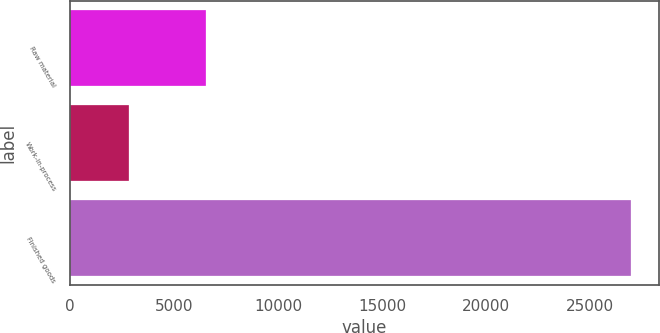<chart> <loc_0><loc_0><loc_500><loc_500><bar_chart><fcel>Raw material<fcel>Work-in-process<fcel>Finished goods<nl><fcel>6555<fcel>2853<fcel>26950<nl></chart> 